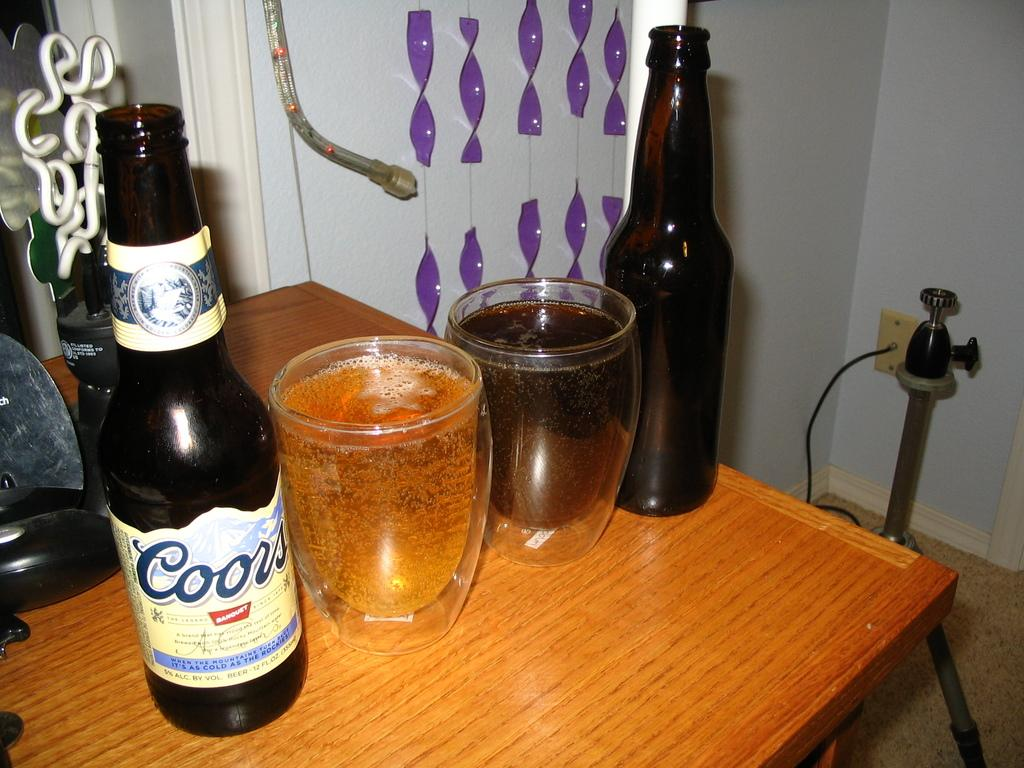<image>
Summarize the visual content of the image. A bottle of Coors beer and another bottle is sitting on a table with two glasses of beer between them. 